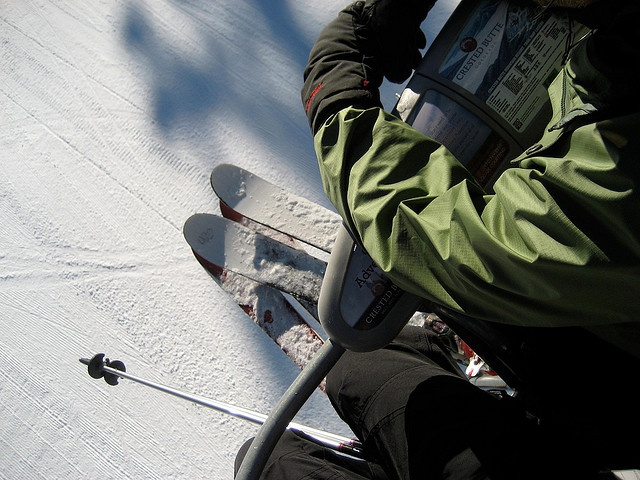Describe the objects in this image and their specific colors. I can see people in lightgray, black, olive, gray, and darkgreen tones, skis in lightgray, gray, and darkgray tones, and skis in lightgray, darkgray, black, and gray tones in this image. 